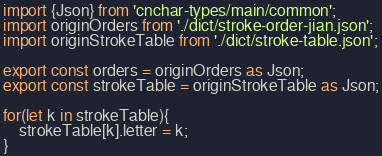<code> <loc_0><loc_0><loc_500><loc_500><_TypeScript_>
import {Json} from 'cnchar-types/main/common';
import originOrders from './dict/stroke-order-jian.json';
import originStrokeTable from './dict/stroke-table.json';

export const orders = originOrders as Json;
export const strokeTable = originStrokeTable as Json;

for(let k in strokeTable){
    strokeTable[k].letter = k;
}</code> 